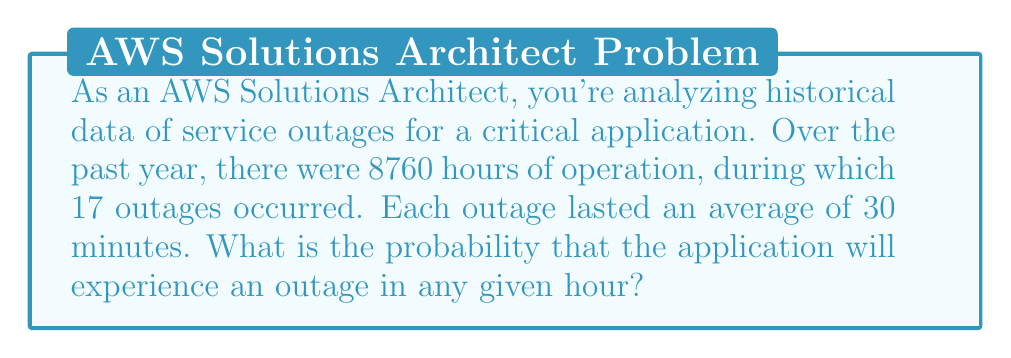Provide a solution to this math problem. Let's approach this step-by-step:

1) First, we need to calculate the total time the application was experiencing outages:
   Number of outages: 17
   Average duration of each outage: 30 minutes = 0.5 hours
   Total outage time = $17 \times 0.5 = 8.5$ hours

2) Now, we can calculate the probability of an outage occurring in any given hour:
   
   Probability = $\frac{\text{Time spent in outage}}{\text{Total time}}$

   $$ P(\text{outage}) = \frac{8.5 \text{ hours}}{8760 \text{ hours}} $$

3) Let's perform the division:

   $$ P(\text{outage}) = \frac{8.5}{8760} \approx 0.000970 $$

4) This can be expressed as a percentage:

   $$ P(\text{outage}) \approx 0.0970\% $$

Therefore, the probability of an outage occurring in any given hour is approximately 0.0970% or 0.000970.
Answer: 0.000970 